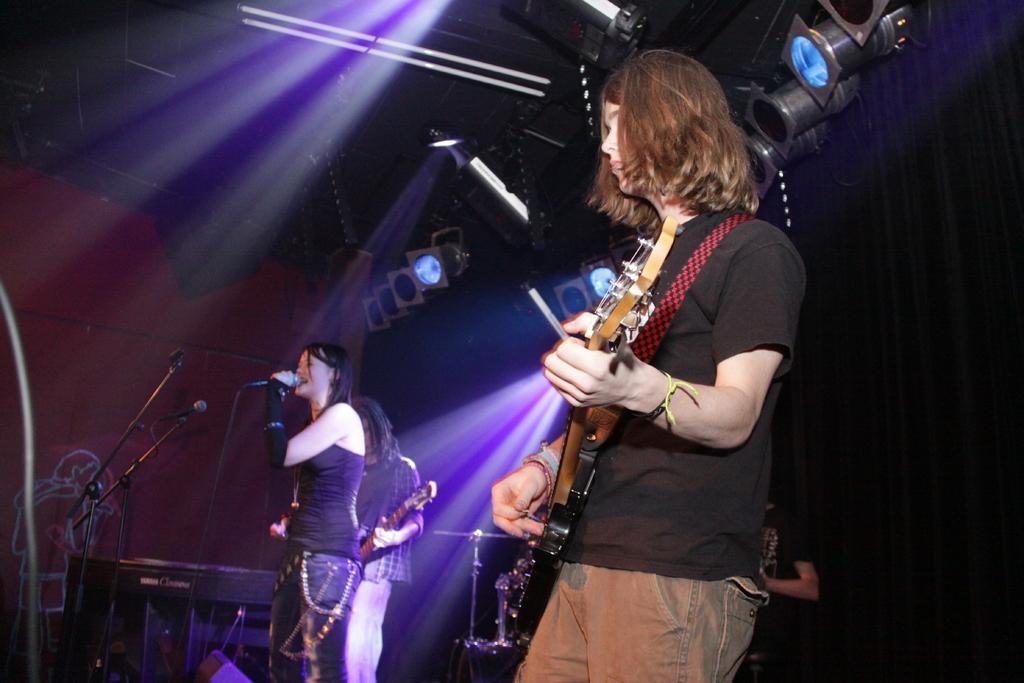In one or two sentences, can you explain what this image depicts? In this picture a woman is singing and woman is playing guitar over here and a person is also playing guitar over here 